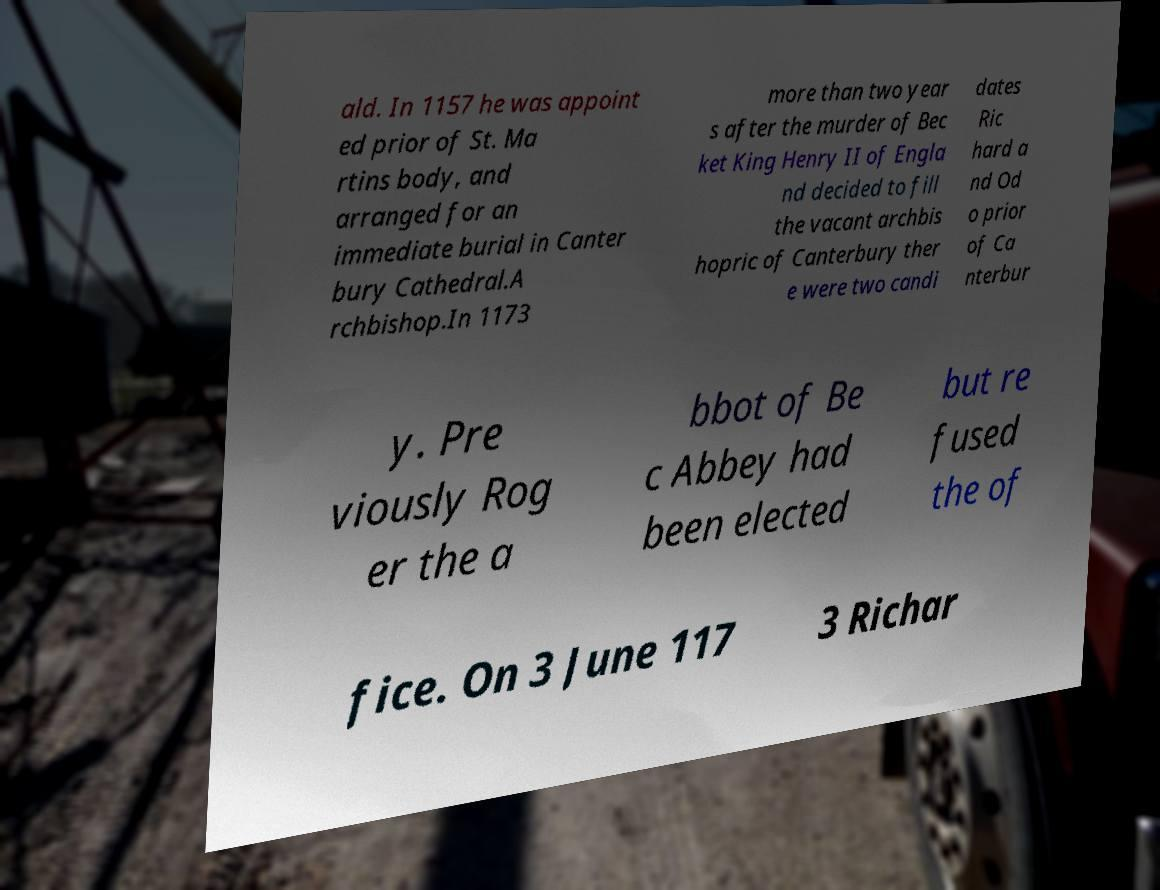Can you accurately transcribe the text from the provided image for me? ald. In 1157 he was appoint ed prior of St. Ma rtins body, and arranged for an immediate burial in Canter bury Cathedral.A rchbishop.In 1173 more than two year s after the murder of Bec ket King Henry II of Engla nd decided to fill the vacant archbis hopric of Canterbury ther e were two candi dates Ric hard a nd Od o prior of Ca nterbur y. Pre viously Rog er the a bbot of Be c Abbey had been elected but re fused the of fice. On 3 June 117 3 Richar 